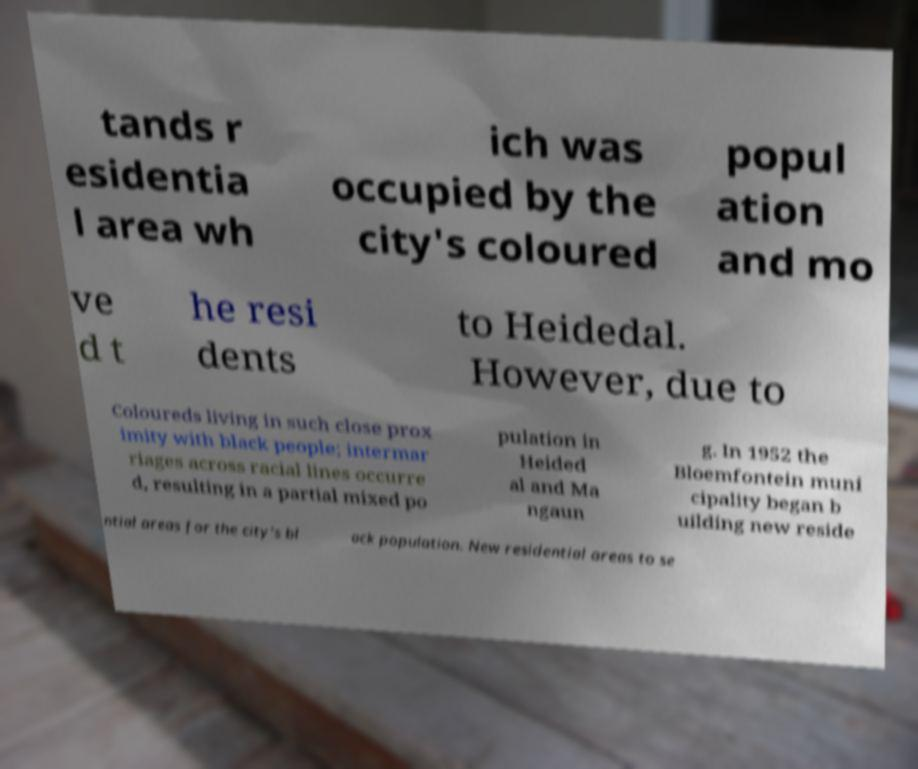Please identify and transcribe the text found in this image. tands r esidentia l area wh ich was occupied by the city's coloured popul ation and mo ve d t he resi dents to Heidedal. However, due to Coloureds living in such close prox imity with black people; intermar riages across racial lines occurre d, resulting in a partial mixed po pulation in Heided al and Ma ngaun g. In 1952 the Bloemfontein muni cipality began b uilding new reside ntial areas for the city's bl ack population. New residential areas to se 